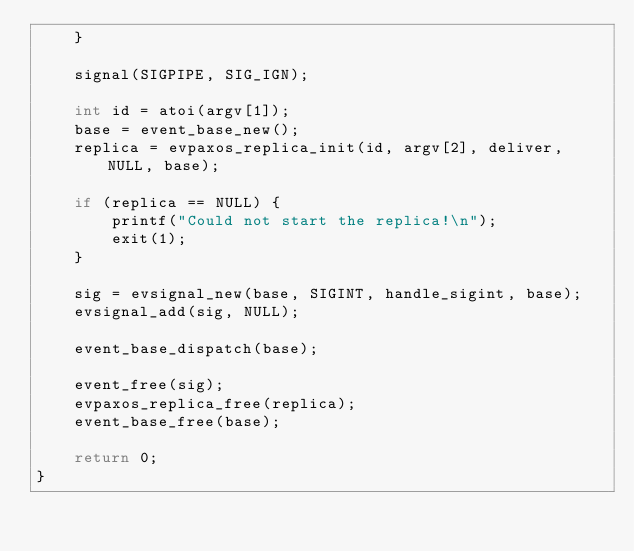Convert code to text. <code><loc_0><loc_0><loc_500><loc_500><_C++_>	}
	
	signal(SIGPIPE, SIG_IGN);
	
	int id = atoi(argv[1]);
	base = event_base_new();
	replica = evpaxos_replica_init(id, argv[2], deliver, NULL, base);
	
	if (replica == NULL) {
		printf("Could not start the replica!\n");
		exit(1);
	}
	
	sig = evsignal_new(base, SIGINT, handle_sigint, base);
	evsignal_add(sig, NULL);
	
	event_base_dispatch(base);

	event_free(sig);
	evpaxos_replica_free(replica);
	event_base_free(base);
	
	return 0;
}
</code> 